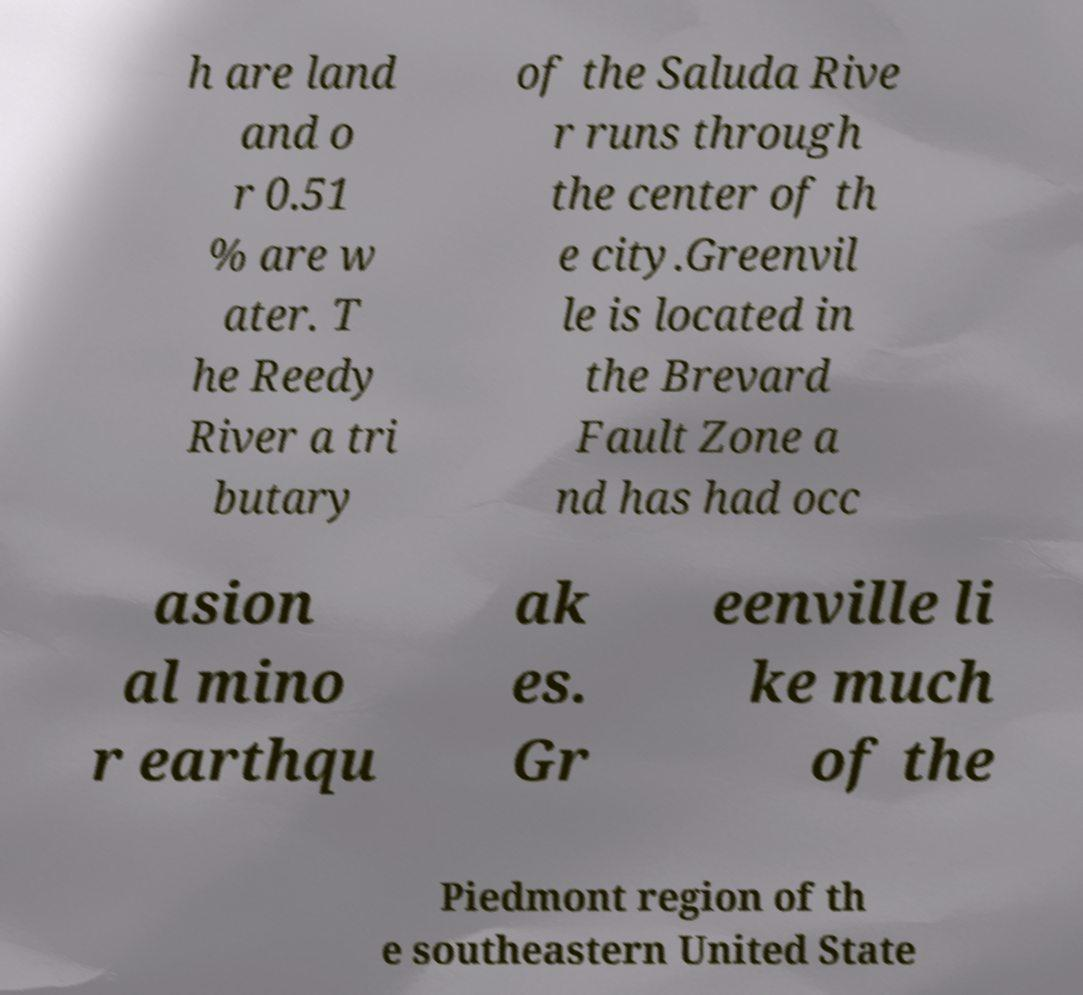Could you assist in decoding the text presented in this image and type it out clearly? h are land and o r 0.51 % are w ater. T he Reedy River a tri butary of the Saluda Rive r runs through the center of th e city.Greenvil le is located in the Brevard Fault Zone a nd has had occ asion al mino r earthqu ak es. Gr eenville li ke much of the Piedmont region of th e southeastern United State 